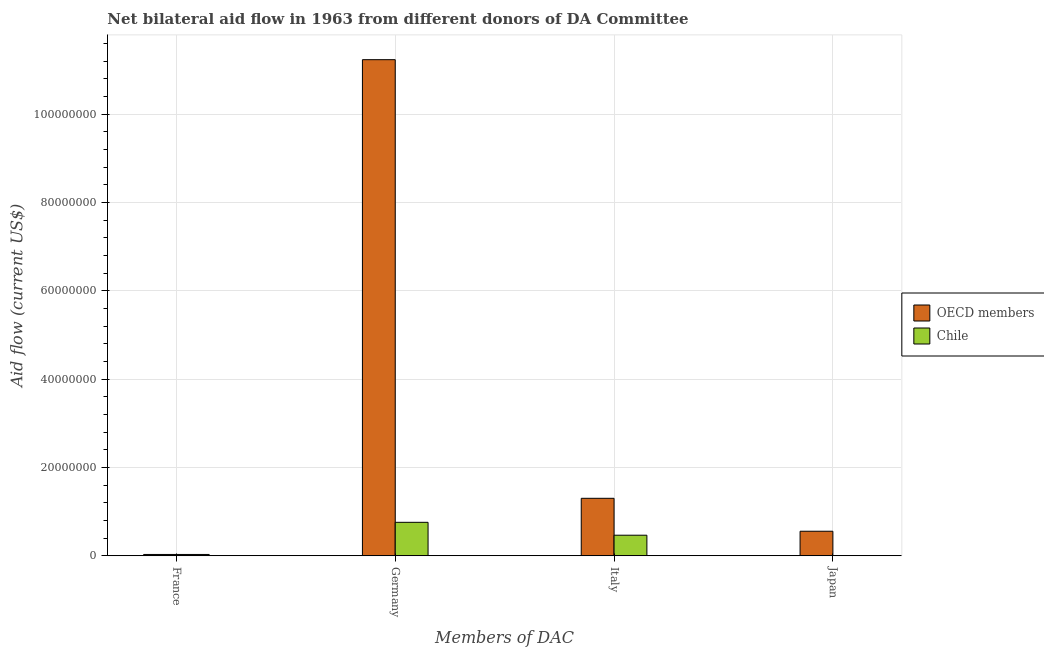Are the number of bars on each tick of the X-axis equal?
Offer a terse response. Yes. How many bars are there on the 1st tick from the right?
Provide a succinct answer. 2. What is the amount of aid given by france in OECD members?
Provide a succinct answer. 3.00e+05. Across all countries, what is the maximum amount of aid given by france?
Give a very brief answer. 3.00e+05. Across all countries, what is the minimum amount of aid given by germany?
Offer a very short reply. 7.58e+06. In which country was the amount of aid given by italy maximum?
Your response must be concise. OECD members. In which country was the amount of aid given by italy minimum?
Offer a very short reply. Chile. What is the total amount of aid given by japan in the graph?
Give a very brief answer. 5.59e+06. What is the difference between the amount of aid given by italy in OECD members and that in Chile?
Provide a succinct answer. 8.36e+06. What is the difference between the amount of aid given by germany in OECD members and the amount of aid given by japan in Chile?
Your answer should be compact. 1.12e+08. What is the difference between the amount of aid given by france and amount of aid given by italy in OECD members?
Your answer should be compact. -1.27e+07. In how many countries, is the amount of aid given by germany greater than 52000000 US$?
Make the answer very short. 1. What is the ratio of the amount of aid given by italy in Chile to that in OECD members?
Provide a short and direct response. 0.36. Is the difference between the amount of aid given by japan in OECD members and Chile greater than the difference between the amount of aid given by germany in OECD members and Chile?
Your answer should be compact. No. What is the difference between the highest and the second highest amount of aid given by france?
Make the answer very short. 0. What is the difference between the highest and the lowest amount of aid given by germany?
Your answer should be very brief. 1.05e+08. Is it the case that in every country, the sum of the amount of aid given by france and amount of aid given by germany is greater than the sum of amount of aid given by japan and amount of aid given by italy?
Make the answer very short. No. What does the 2nd bar from the right in Italy represents?
Ensure brevity in your answer.  OECD members. Is it the case that in every country, the sum of the amount of aid given by france and amount of aid given by germany is greater than the amount of aid given by italy?
Offer a terse response. Yes. Are the values on the major ticks of Y-axis written in scientific E-notation?
Ensure brevity in your answer.  No. How many legend labels are there?
Your response must be concise. 2. How are the legend labels stacked?
Give a very brief answer. Vertical. What is the title of the graph?
Provide a short and direct response. Net bilateral aid flow in 1963 from different donors of DA Committee. Does "Saudi Arabia" appear as one of the legend labels in the graph?
Offer a very short reply. No. What is the label or title of the X-axis?
Your answer should be compact. Members of DAC. What is the Aid flow (current US$) in OECD members in France?
Your response must be concise. 3.00e+05. What is the Aid flow (current US$) in OECD members in Germany?
Provide a succinct answer. 1.12e+08. What is the Aid flow (current US$) in Chile in Germany?
Your answer should be compact. 7.58e+06. What is the Aid flow (current US$) of OECD members in Italy?
Ensure brevity in your answer.  1.30e+07. What is the Aid flow (current US$) of Chile in Italy?
Offer a terse response. 4.66e+06. What is the Aid flow (current US$) in OECD members in Japan?
Provide a short and direct response. 5.56e+06. What is the Aid flow (current US$) of Chile in Japan?
Give a very brief answer. 3.00e+04. Across all Members of DAC, what is the maximum Aid flow (current US$) in OECD members?
Ensure brevity in your answer.  1.12e+08. Across all Members of DAC, what is the maximum Aid flow (current US$) in Chile?
Your answer should be very brief. 7.58e+06. Across all Members of DAC, what is the minimum Aid flow (current US$) in OECD members?
Offer a terse response. 3.00e+05. Across all Members of DAC, what is the minimum Aid flow (current US$) of Chile?
Make the answer very short. 3.00e+04. What is the total Aid flow (current US$) of OECD members in the graph?
Keep it short and to the point. 1.31e+08. What is the total Aid flow (current US$) of Chile in the graph?
Ensure brevity in your answer.  1.26e+07. What is the difference between the Aid flow (current US$) in OECD members in France and that in Germany?
Provide a short and direct response. -1.12e+08. What is the difference between the Aid flow (current US$) in Chile in France and that in Germany?
Keep it short and to the point. -7.28e+06. What is the difference between the Aid flow (current US$) of OECD members in France and that in Italy?
Ensure brevity in your answer.  -1.27e+07. What is the difference between the Aid flow (current US$) of Chile in France and that in Italy?
Your response must be concise. -4.36e+06. What is the difference between the Aid flow (current US$) in OECD members in France and that in Japan?
Keep it short and to the point. -5.26e+06. What is the difference between the Aid flow (current US$) in OECD members in Germany and that in Italy?
Your answer should be compact. 9.93e+07. What is the difference between the Aid flow (current US$) in Chile in Germany and that in Italy?
Ensure brevity in your answer.  2.92e+06. What is the difference between the Aid flow (current US$) of OECD members in Germany and that in Japan?
Your answer should be compact. 1.07e+08. What is the difference between the Aid flow (current US$) of Chile in Germany and that in Japan?
Ensure brevity in your answer.  7.55e+06. What is the difference between the Aid flow (current US$) in OECD members in Italy and that in Japan?
Your answer should be very brief. 7.46e+06. What is the difference between the Aid flow (current US$) of Chile in Italy and that in Japan?
Your answer should be very brief. 4.63e+06. What is the difference between the Aid flow (current US$) of OECD members in France and the Aid flow (current US$) of Chile in Germany?
Your response must be concise. -7.28e+06. What is the difference between the Aid flow (current US$) in OECD members in France and the Aid flow (current US$) in Chile in Italy?
Provide a short and direct response. -4.36e+06. What is the difference between the Aid flow (current US$) in OECD members in France and the Aid flow (current US$) in Chile in Japan?
Ensure brevity in your answer.  2.70e+05. What is the difference between the Aid flow (current US$) of OECD members in Germany and the Aid flow (current US$) of Chile in Italy?
Provide a short and direct response. 1.08e+08. What is the difference between the Aid flow (current US$) of OECD members in Germany and the Aid flow (current US$) of Chile in Japan?
Ensure brevity in your answer.  1.12e+08. What is the difference between the Aid flow (current US$) in OECD members in Italy and the Aid flow (current US$) in Chile in Japan?
Give a very brief answer. 1.30e+07. What is the average Aid flow (current US$) of OECD members per Members of DAC?
Give a very brief answer. 3.28e+07. What is the average Aid flow (current US$) of Chile per Members of DAC?
Make the answer very short. 3.14e+06. What is the difference between the Aid flow (current US$) in OECD members and Aid flow (current US$) in Chile in Germany?
Provide a short and direct response. 1.05e+08. What is the difference between the Aid flow (current US$) in OECD members and Aid flow (current US$) in Chile in Italy?
Ensure brevity in your answer.  8.36e+06. What is the difference between the Aid flow (current US$) of OECD members and Aid flow (current US$) of Chile in Japan?
Your answer should be compact. 5.53e+06. What is the ratio of the Aid flow (current US$) in OECD members in France to that in Germany?
Provide a succinct answer. 0. What is the ratio of the Aid flow (current US$) in Chile in France to that in Germany?
Your answer should be compact. 0.04. What is the ratio of the Aid flow (current US$) of OECD members in France to that in Italy?
Offer a terse response. 0.02. What is the ratio of the Aid flow (current US$) in Chile in France to that in Italy?
Offer a terse response. 0.06. What is the ratio of the Aid flow (current US$) of OECD members in France to that in Japan?
Provide a succinct answer. 0.05. What is the ratio of the Aid flow (current US$) of OECD members in Germany to that in Italy?
Offer a very short reply. 8.63. What is the ratio of the Aid flow (current US$) of Chile in Germany to that in Italy?
Offer a terse response. 1.63. What is the ratio of the Aid flow (current US$) of OECD members in Germany to that in Japan?
Offer a terse response. 20.21. What is the ratio of the Aid flow (current US$) in Chile in Germany to that in Japan?
Offer a terse response. 252.67. What is the ratio of the Aid flow (current US$) of OECD members in Italy to that in Japan?
Your answer should be compact. 2.34. What is the ratio of the Aid flow (current US$) of Chile in Italy to that in Japan?
Provide a short and direct response. 155.33. What is the difference between the highest and the second highest Aid flow (current US$) of OECD members?
Your answer should be very brief. 9.93e+07. What is the difference between the highest and the second highest Aid flow (current US$) in Chile?
Make the answer very short. 2.92e+06. What is the difference between the highest and the lowest Aid flow (current US$) in OECD members?
Provide a short and direct response. 1.12e+08. What is the difference between the highest and the lowest Aid flow (current US$) of Chile?
Provide a succinct answer. 7.55e+06. 